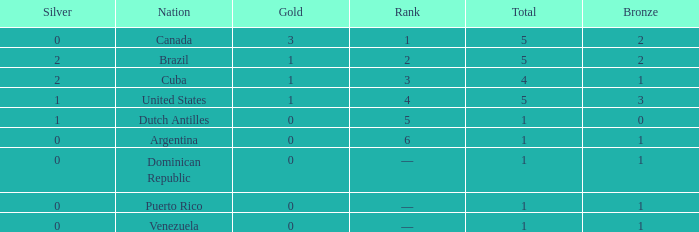What is the average gold total for nations ranked 6 with 1 total medal and 1 bronze medal? None. 